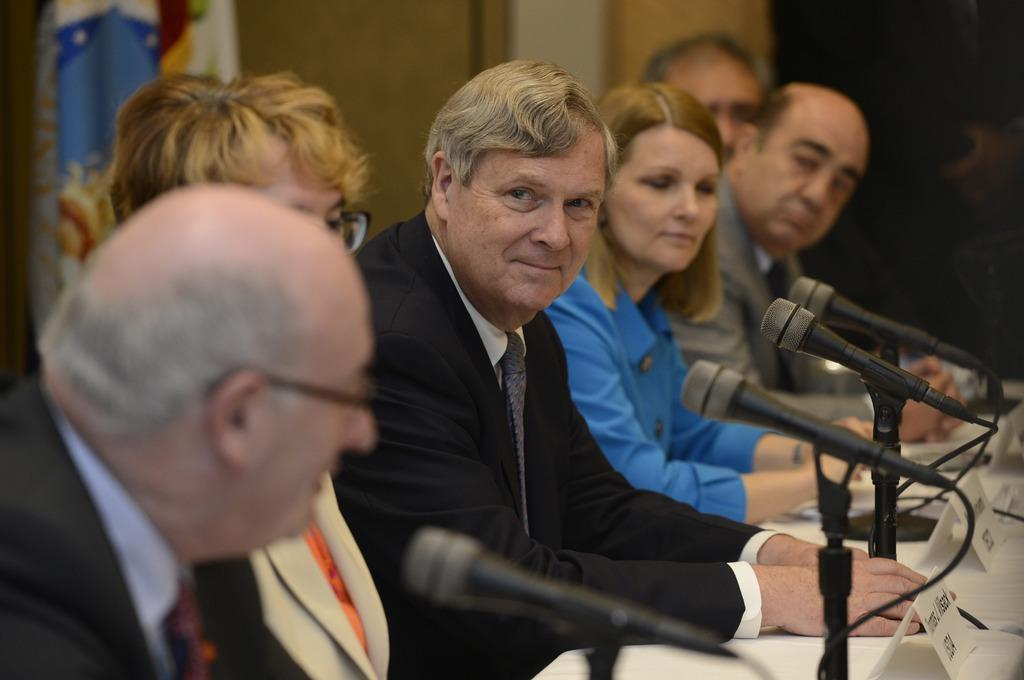Who or what is in front of the mic in the image? There are people in front of the mic in the image. What might the people be doing in front of the mic? They might be singing, speaking, or performing in some way. What else can be seen in the image besides the people and the mic? There are boards on a table in the image. Can you see any holes in the image? There is no mention of any holes in the provided facts, so we cannot determine if there are any holes present in the image. 